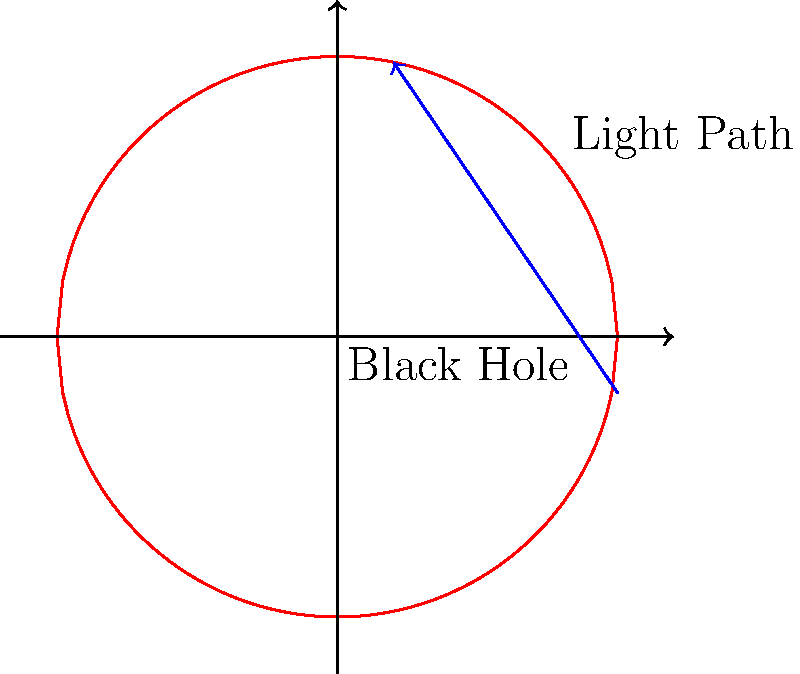In a survival situation near a black hole, understanding light paths is crucial. Given the curved space-time represented by the red circle, how would the path of light (blue arrow) be affected as it approaches the black hole's event horizon? To understand the path of light near a black hole, we need to consider the following steps:

1. General Relativity: Einstein's theory states that massive objects curve space-time.

2. Black Hole Curvature: Black holes create extreme curvature in space-time, represented by the red circle in the diagram.

3. Light Path in Flat Space-Time: In the absence of gravity, light would travel in a straight line.

4. Gravitational Lensing: As light approaches the black hole, it follows the curvature of space-time.

5. Event Horizon: The event horizon is the point of no return, where even light cannot escape the black hole's gravity.

6. Light Bending: The blue arrow shows how light bends around the black hole due to the curved space-time.

7. Survival Implications: Understanding this phenomenon is crucial for navigation and communication in extreme gravitational environments.

The light path will curve around the black hole, following the shape of space-time. This effect is known as gravitational lensing. The closer the light gets to the event horizon, the more extreme the bending becomes. If the light crosses the event horizon, it will be trapped within the black hole.
Answer: Light bends around the black hole, following the curvature of space-time. 